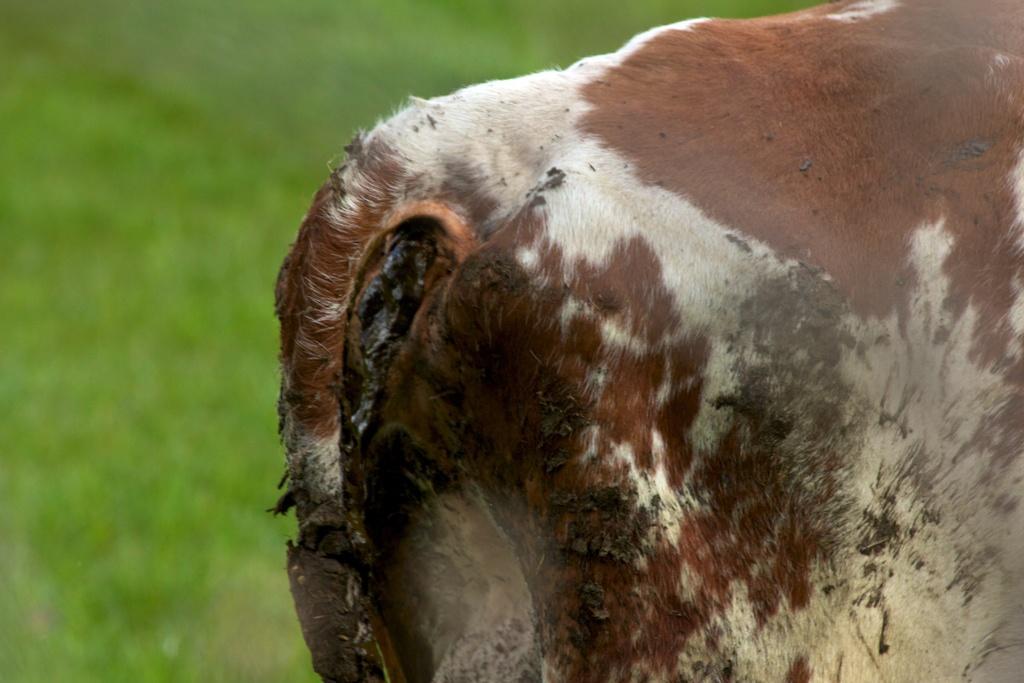In one or two sentences, can you explain what this image depicts? In this picture we can see the close view of the brown and white color cow from the backside. Behind there is a blur background. 